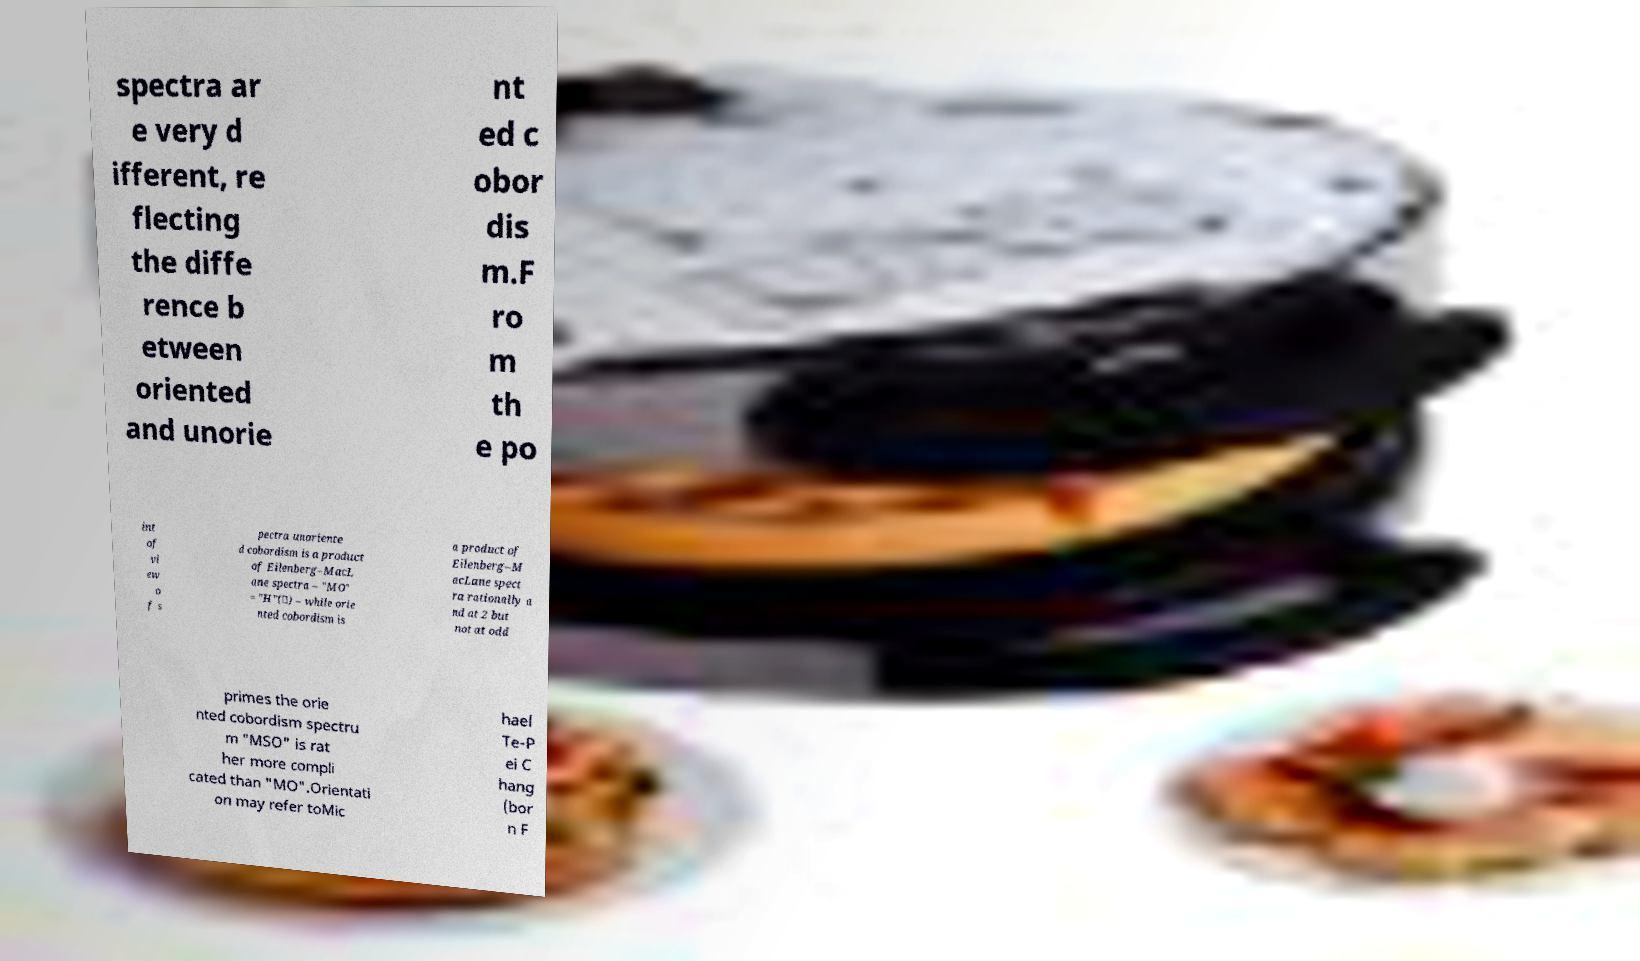Please identify and transcribe the text found in this image. spectra ar e very d ifferent, re flecting the diffe rence b etween oriented and unorie nt ed c obor dis m.F ro m th e po int of vi ew o f s pectra unoriente d cobordism is a product of Eilenberg–MacL ane spectra – "MO" = "H"(∗) – while orie nted cobordism is a product of Eilenberg–M acLane spect ra rationally a nd at 2 but not at odd primes the orie nted cobordism spectru m "MSO" is rat her more compli cated than "MO".Orientati on may refer toMic hael Te-P ei C hang (bor n F 